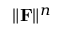<formula> <loc_0><loc_0><loc_500><loc_500>\| \mathbf F \| ^ { n }</formula> 